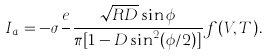Convert formula to latex. <formula><loc_0><loc_0><loc_500><loc_500>I _ { a } = - \sigma \frac { e } { } \frac { \sqrt { R D } \sin \phi } { \pi [ 1 - D \sin ^ { 2 } ( \phi / 2 ) ] } f ( V , T ) .</formula> 